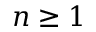<formula> <loc_0><loc_0><loc_500><loc_500>n \geq 1</formula> 